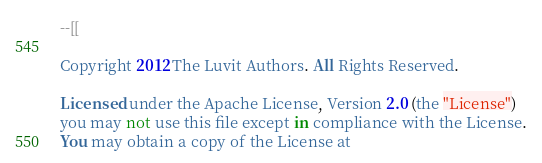<code> <loc_0><loc_0><loc_500><loc_500><_Lua_>--[[

Copyright 2012 The Luvit Authors. All Rights Reserved.

Licensed under the Apache License, Version 2.0 (the "License")
you may not use this file except in compliance with the License.
You may obtain a copy of the License at
</code> 